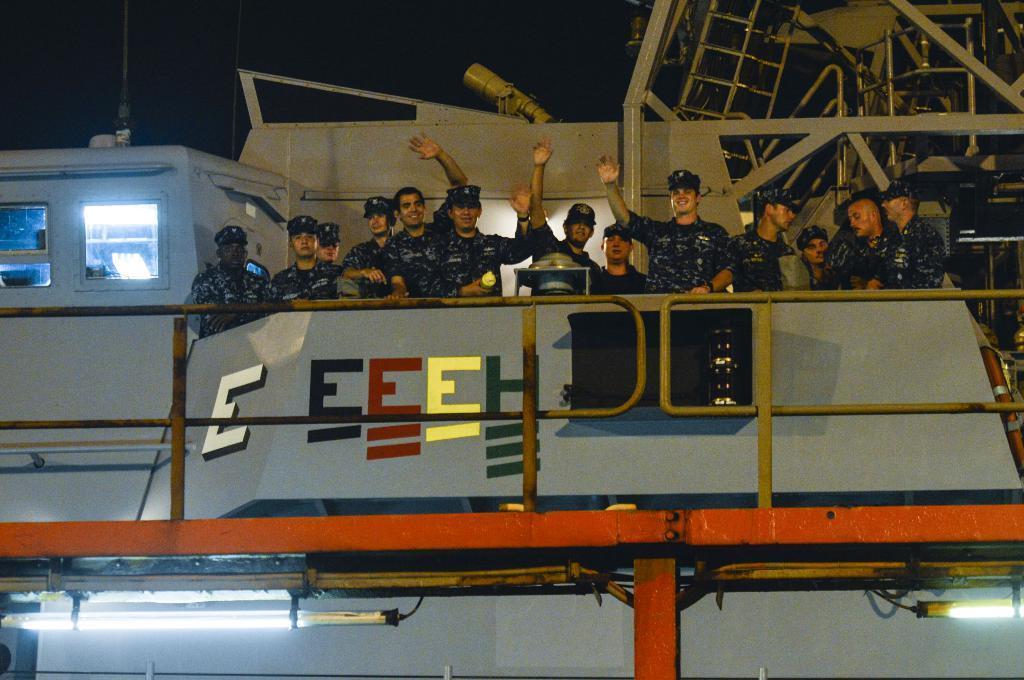Could you give a brief overview of what you see in this image? In this image I can see a ship which is grey in color and few persons wearing black color uniform are standing on the ship. I can see the orange colored railing and in the background I can see the dark sky. 